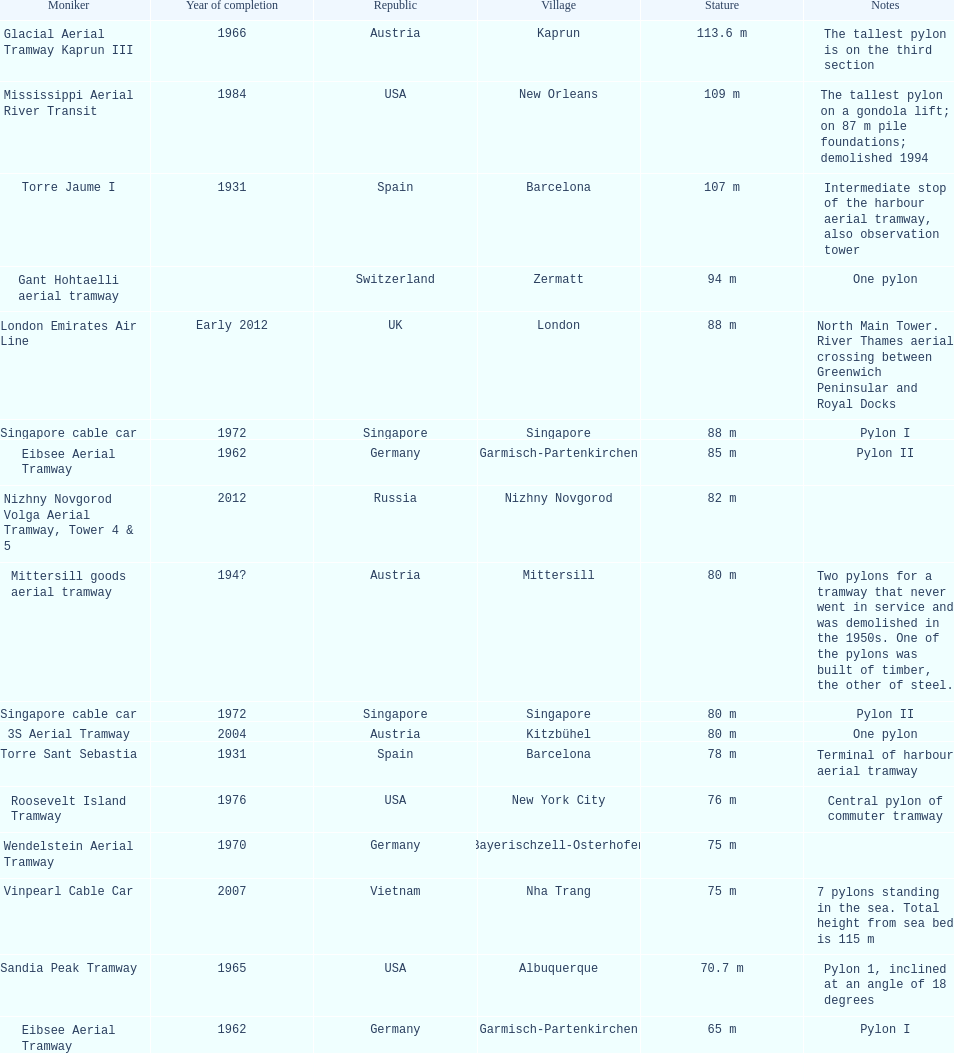What is the total number of tallest pylons in austria? 3. 